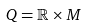Convert formula to latex. <formula><loc_0><loc_0><loc_500><loc_500>Q = \mathbb { R } \times M</formula> 